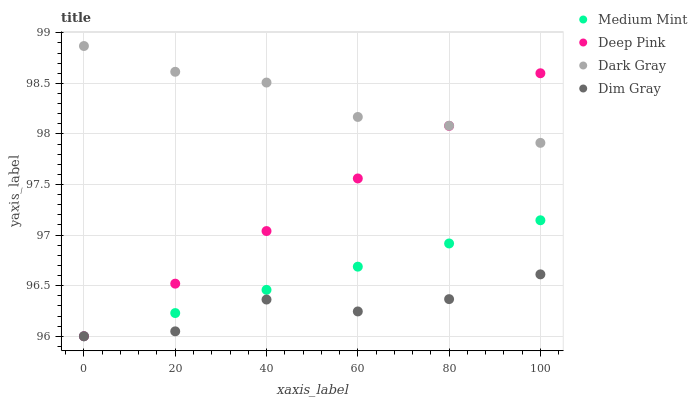Does Dim Gray have the minimum area under the curve?
Answer yes or no. Yes. Does Dark Gray have the maximum area under the curve?
Answer yes or no. Yes. Does Dark Gray have the minimum area under the curve?
Answer yes or no. No. Does Dim Gray have the maximum area under the curve?
Answer yes or no. No. Is Deep Pink the smoothest?
Answer yes or no. Yes. Is Dim Gray the roughest?
Answer yes or no. Yes. Is Dark Gray the smoothest?
Answer yes or no. No. Is Dark Gray the roughest?
Answer yes or no. No. Does Medium Mint have the lowest value?
Answer yes or no. Yes. Does Dark Gray have the lowest value?
Answer yes or no. No. Does Dark Gray have the highest value?
Answer yes or no. Yes. Does Dim Gray have the highest value?
Answer yes or no. No. Is Medium Mint less than Dark Gray?
Answer yes or no. Yes. Is Dark Gray greater than Medium Mint?
Answer yes or no. Yes. Does Medium Mint intersect Dim Gray?
Answer yes or no. Yes. Is Medium Mint less than Dim Gray?
Answer yes or no. No. Is Medium Mint greater than Dim Gray?
Answer yes or no. No. Does Medium Mint intersect Dark Gray?
Answer yes or no. No. 